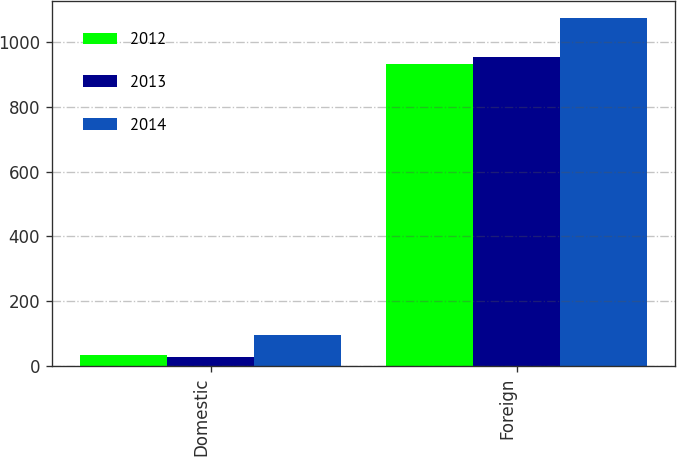Convert chart. <chart><loc_0><loc_0><loc_500><loc_500><stacked_bar_chart><ecel><fcel>Domestic<fcel>Foreign<nl><fcel>2012<fcel>34.7<fcel>933.5<nl><fcel>2013<fcel>28.4<fcel>955.3<nl><fcel>2014<fcel>94.8<fcel>1074<nl></chart> 